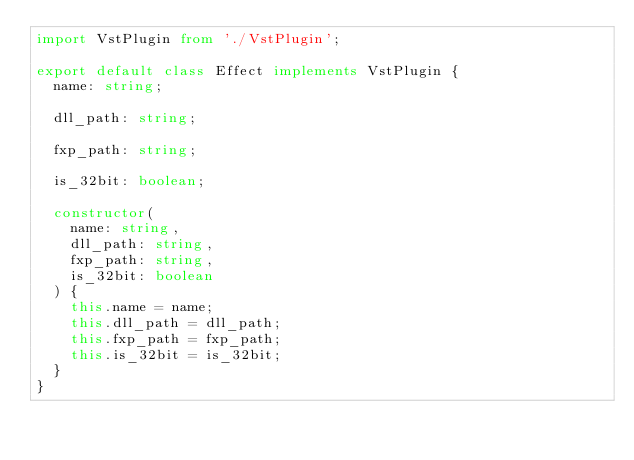Convert code to text. <code><loc_0><loc_0><loc_500><loc_500><_TypeScript_>import VstPlugin from './VstPlugin';

export default class Effect implements VstPlugin {
  name: string;

  dll_path: string;

  fxp_path: string;

  is_32bit: boolean;

  constructor(
    name: string,
    dll_path: string,
    fxp_path: string,
    is_32bit: boolean
  ) {
    this.name = name;
    this.dll_path = dll_path;
    this.fxp_path = fxp_path;
    this.is_32bit = is_32bit;
  }
}
</code> 